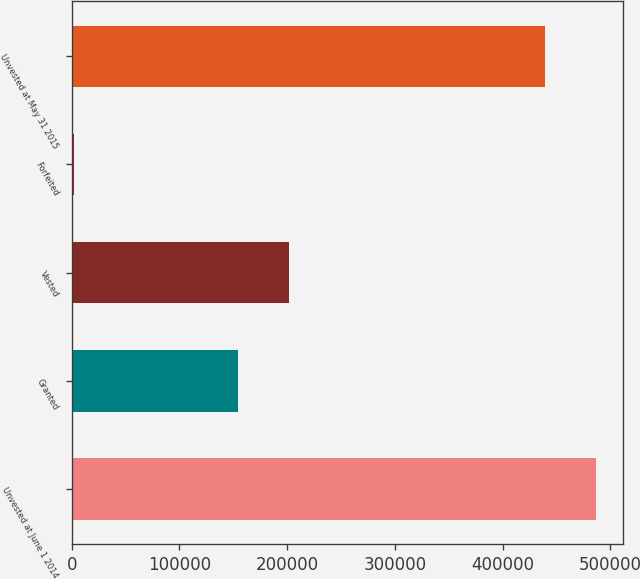Convert chart to OTSL. <chart><loc_0><loc_0><loc_500><loc_500><bar_chart><fcel>Unvested at June 1 2014<fcel>Granted<fcel>Vested<fcel>Forfeited<fcel>Unvested at May 31 2015<nl><fcel>486827<fcel>154115<fcel>201900<fcel>2310<fcel>439042<nl></chart> 